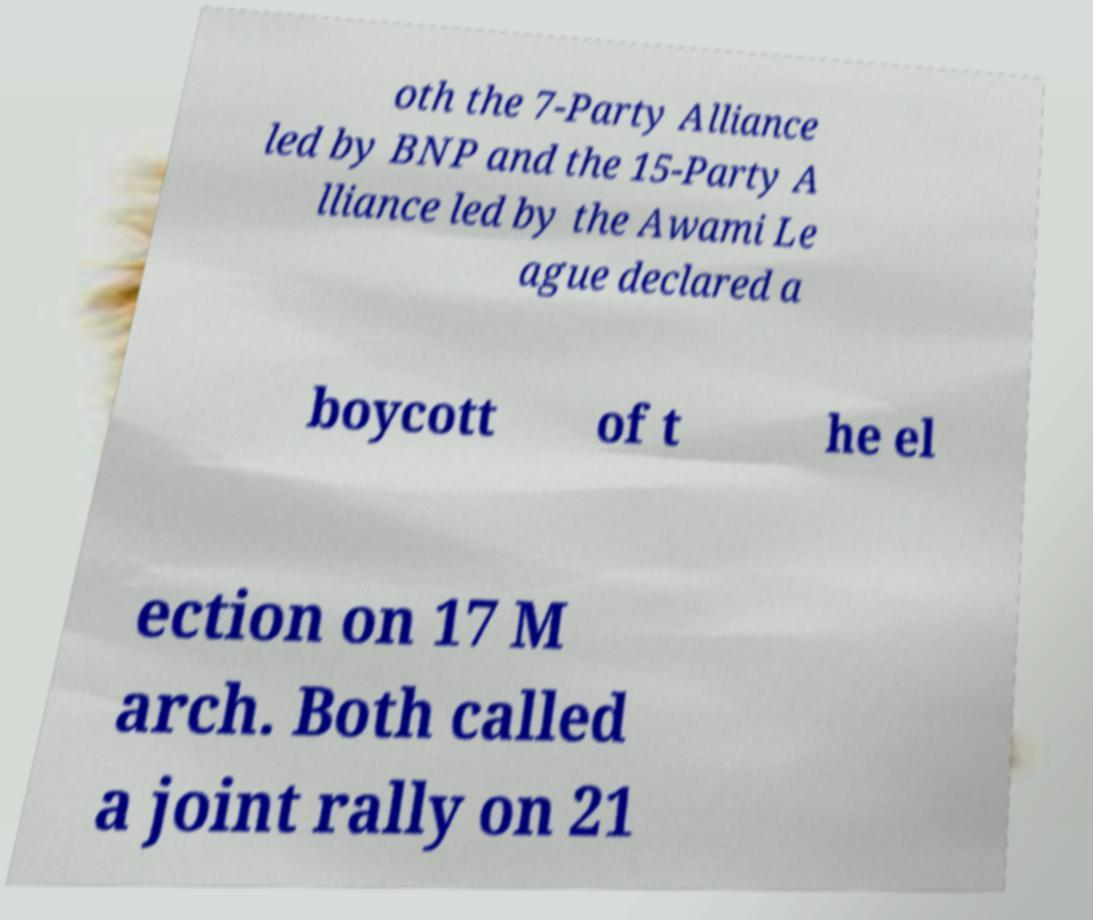I need the written content from this picture converted into text. Can you do that? oth the 7-Party Alliance led by BNP and the 15-Party A lliance led by the Awami Le ague declared a boycott of t he el ection on 17 M arch. Both called a joint rally on 21 